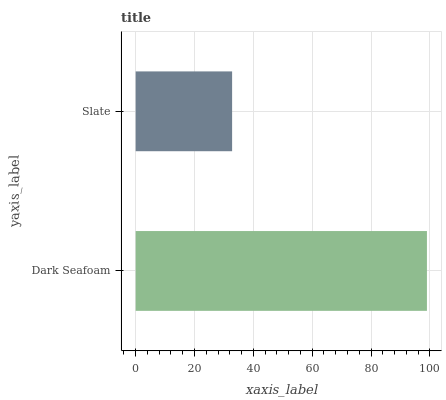Is Slate the minimum?
Answer yes or no. Yes. Is Dark Seafoam the maximum?
Answer yes or no. Yes. Is Slate the maximum?
Answer yes or no. No. Is Dark Seafoam greater than Slate?
Answer yes or no. Yes. Is Slate less than Dark Seafoam?
Answer yes or no. Yes. Is Slate greater than Dark Seafoam?
Answer yes or no. No. Is Dark Seafoam less than Slate?
Answer yes or no. No. Is Dark Seafoam the high median?
Answer yes or no. Yes. Is Slate the low median?
Answer yes or no. Yes. Is Slate the high median?
Answer yes or no. No. Is Dark Seafoam the low median?
Answer yes or no. No. 